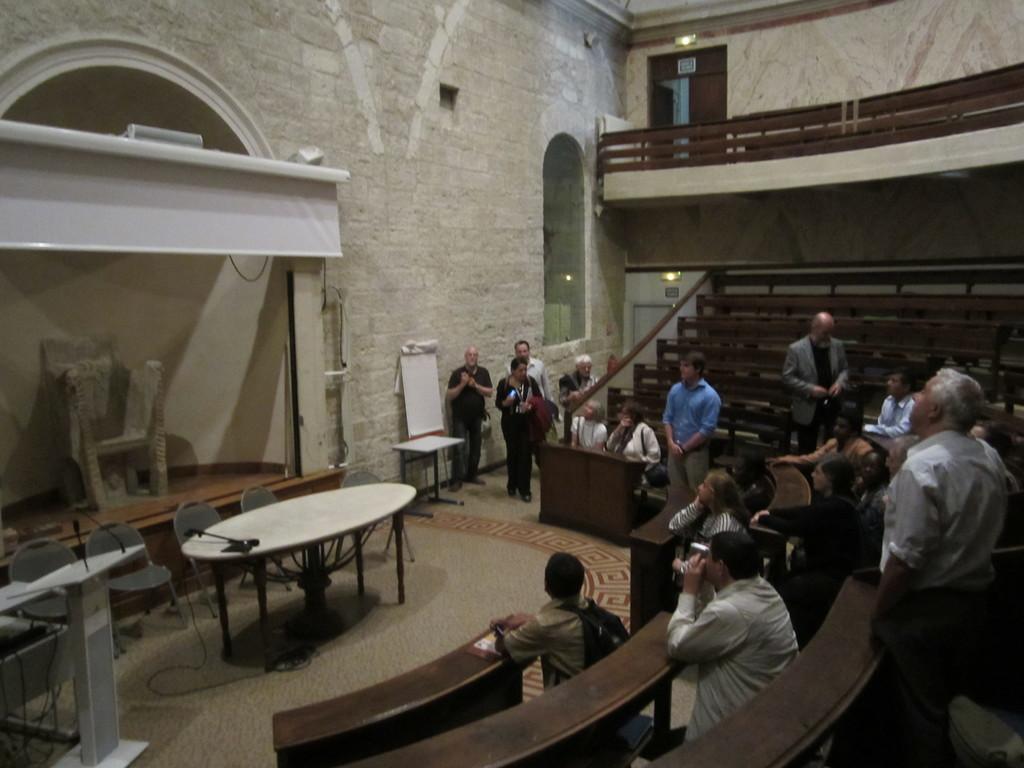In one or two sentences, can you explain what this image depicts? Some persons are sitting on the benches. Some are standing. This is a room. There are table chairs in this room. There is a board near the wall. There is an arch. 